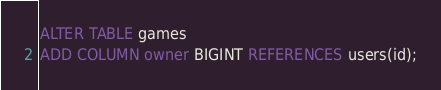Convert code to text. <code><loc_0><loc_0><loc_500><loc_500><_SQL_>ALTER TABLE games
ADD COLUMN owner BIGINT REFERENCES users(id);
</code> 